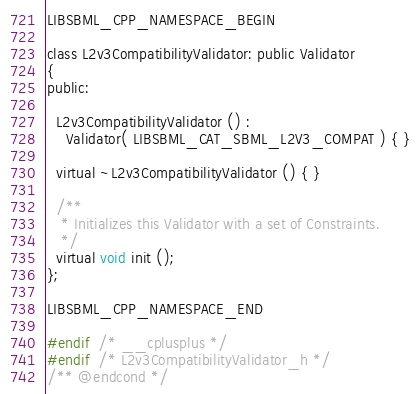<code> <loc_0><loc_0><loc_500><loc_500><_C_>LIBSBML_CPP_NAMESPACE_BEGIN

class L2v3CompatibilityValidator: public Validator
{
public:

  L2v3CompatibilityValidator () :
    Validator( LIBSBML_CAT_SBML_L2V3_COMPAT ) { }

  virtual ~L2v3CompatibilityValidator () { }

  /**
   * Initializes this Validator with a set of Constraints.
   */
  virtual void init ();
};

LIBSBML_CPP_NAMESPACE_END

#endif  /* __cplusplus */
#endif  /* L2v3CompatibilityValidator_h */
/** @endcond */

</code> 